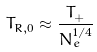<formula> <loc_0><loc_0><loc_500><loc_500>T _ { R , 0 } \approx \frac { T _ { + } } { \bar { N } _ { e } ^ { 1 / 4 } }</formula> 